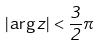<formula> <loc_0><loc_0><loc_500><loc_500>| \arg z | < \frac { 3 } { 2 } \pi</formula> 